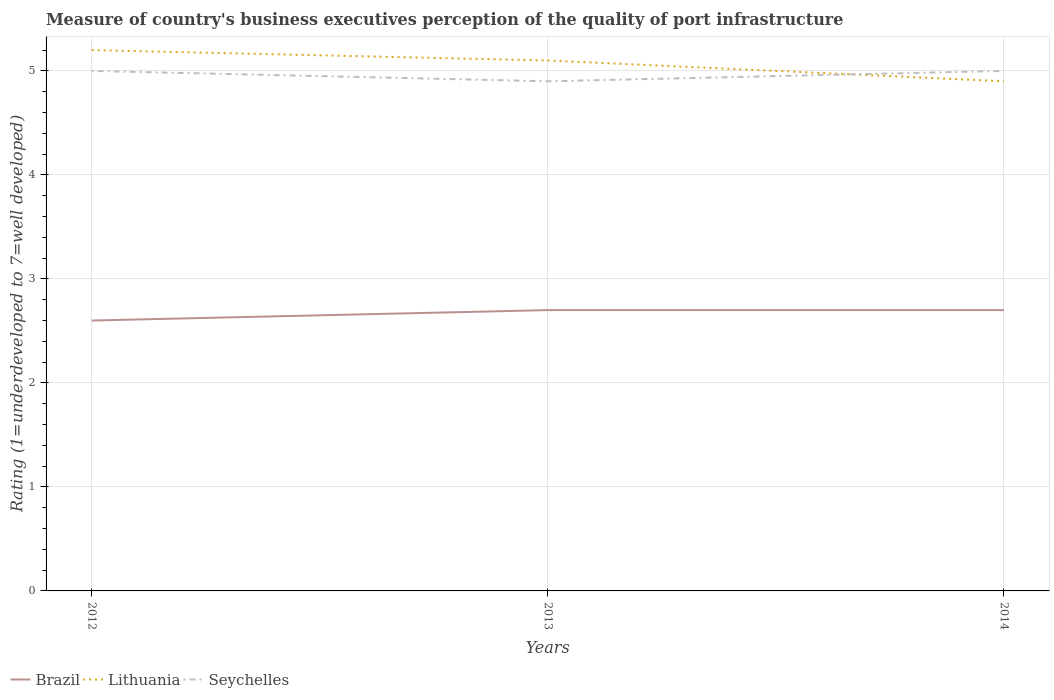How many different coloured lines are there?
Offer a very short reply. 3. What is the total ratings of the quality of port infrastructure in Lithuania in the graph?
Keep it short and to the point. 0.3. What is the difference between the highest and the second highest ratings of the quality of port infrastructure in Lithuania?
Offer a terse response. 0.3. Is the ratings of the quality of port infrastructure in Lithuania strictly greater than the ratings of the quality of port infrastructure in Seychelles over the years?
Keep it short and to the point. No. How many lines are there?
Provide a succinct answer. 3. What is the difference between two consecutive major ticks on the Y-axis?
Give a very brief answer. 1. Does the graph contain any zero values?
Your answer should be very brief. No. Does the graph contain grids?
Keep it short and to the point. Yes. How are the legend labels stacked?
Give a very brief answer. Horizontal. What is the title of the graph?
Ensure brevity in your answer.  Measure of country's business executives perception of the quality of port infrastructure. Does "Korea (Democratic)" appear as one of the legend labels in the graph?
Offer a terse response. No. What is the label or title of the X-axis?
Provide a short and direct response. Years. What is the label or title of the Y-axis?
Your answer should be very brief. Rating (1=underdeveloped to 7=well developed). What is the Rating (1=underdeveloped to 7=well developed) of Brazil in 2012?
Your answer should be very brief. 2.6. What is the Rating (1=underdeveloped to 7=well developed) of Lithuania in 2012?
Your response must be concise. 5.2. What is the Rating (1=underdeveloped to 7=well developed) of Brazil in 2013?
Your answer should be compact. 2.7. What is the Rating (1=underdeveloped to 7=well developed) in Brazil in 2014?
Offer a terse response. 2.7. Across all years, what is the maximum Rating (1=underdeveloped to 7=well developed) in Brazil?
Your answer should be very brief. 2.7. Across all years, what is the maximum Rating (1=underdeveloped to 7=well developed) of Seychelles?
Keep it short and to the point. 5. Across all years, what is the minimum Rating (1=underdeveloped to 7=well developed) in Lithuania?
Offer a very short reply. 4.9. Across all years, what is the minimum Rating (1=underdeveloped to 7=well developed) in Seychelles?
Provide a succinct answer. 4.9. What is the difference between the Rating (1=underdeveloped to 7=well developed) of Brazil in 2012 and that in 2013?
Provide a succinct answer. -0.1. What is the difference between the Rating (1=underdeveloped to 7=well developed) in Seychelles in 2012 and that in 2014?
Give a very brief answer. 0. What is the difference between the Rating (1=underdeveloped to 7=well developed) in Brazil in 2013 and that in 2014?
Offer a very short reply. 0. What is the difference between the Rating (1=underdeveloped to 7=well developed) of Brazil in 2012 and the Rating (1=underdeveloped to 7=well developed) of Lithuania in 2013?
Give a very brief answer. -2.5. What is the difference between the Rating (1=underdeveloped to 7=well developed) of Brazil in 2012 and the Rating (1=underdeveloped to 7=well developed) of Seychelles in 2013?
Give a very brief answer. -2.3. What is the difference between the Rating (1=underdeveloped to 7=well developed) in Brazil in 2013 and the Rating (1=underdeveloped to 7=well developed) in Lithuania in 2014?
Your answer should be compact. -2.2. What is the average Rating (1=underdeveloped to 7=well developed) of Brazil per year?
Offer a very short reply. 2.67. What is the average Rating (1=underdeveloped to 7=well developed) in Lithuania per year?
Provide a short and direct response. 5.07. What is the average Rating (1=underdeveloped to 7=well developed) in Seychelles per year?
Offer a very short reply. 4.97. In the year 2012, what is the difference between the Rating (1=underdeveloped to 7=well developed) in Brazil and Rating (1=underdeveloped to 7=well developed) in Lithuania?
Provide a succinct answer. -2.6. In the year 2012, what is the difference between the Rating (1=underdeveloped to 7=well developed) of Brazil and Rating (1=underdeveloped to 7=well developed) of Seychelles?
Your answer should be very brief. -2.4. In the year 2012, what is the difference between the Rating (1=underdeveloped to 7=well developed) of Lithuania and Rating (1=underdeveloped to 7=well developed) of Seychelles?
Offer a terse response. 0.2. In the year 2014, what is the difference between the Rating (1=underdeveloped to 7=well developed) in Brazil and Rating (1=underdeveloped to 7=well developed) in Lithuania?
Give a very brief answer. -2.2. In the year 2014, what is the difference between the Rating (1=underdeveloped to 7=well developed) in Lithuania and Rating (1=underdeveloped to 7=well developed) in Seychelles?
Provide a short and direct response. -0.1. What is the ratio of the Rating (1=underdeveloped to 7=well developed) of Lithuania in 2012 to that in 2013?
Your answer should be very brief. 1.02. What is the ratio of the Rating (1=underdeveloped to 7=well developed) of Seychelles in 2012 to that in 2013?
Keep it short and to the point. 1.02. What is the ratio of the Rating (1=underdeveloped to 7=well developed) in Brazil in 2012 to that in 2014?
Your answer should be very brief. 0.96. What is the ratio of the Rating (1=underdeveloped to 7=well developed) of Lithuania in 2012 to that in 2014?
Your answer should be compact. 1.06. What is the ratio of the Rating (1=underdeveloped to 7=well developed) of Lithuania in 2013 to that in 2014?
Make the answer very short. 1.04. What is the difference between the highest and the second highest Rating (1=underdeveloped to 7=well developed) in Brazil?
Provide a succinct answer. 0. What is the difference between the highest and the second highest Rating (1=underdeveloped to 7=well developed) of Lithuania?
Provide a succinct answer. 0.1. What is the difference between the highest and the second highest Rating (1=underdeveloped to 7=well developed) in Seychelles?
Provide a succinct answer. 0. What is the difference between the highest and the lowest Rating (1=underdeveloped to 7=well developed) in Lithuania?
Provide a succinct answer. 0.3. 